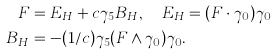<formula> <loc_0><loc_0><loc_500><loc_500>F & = E _ { H } + c \gamma _ { 5 } B _ { H } , \quad E _ { H } = ( F \cdot \gamma _ { 0 } ) \gamma _ { 0 } \\ B _ { H } & = - ( 1 / c ) \gamma _ { 5 } ( F \wedge \gamma _ { 0 } ) \gamma _ { 0 } .</formula> 